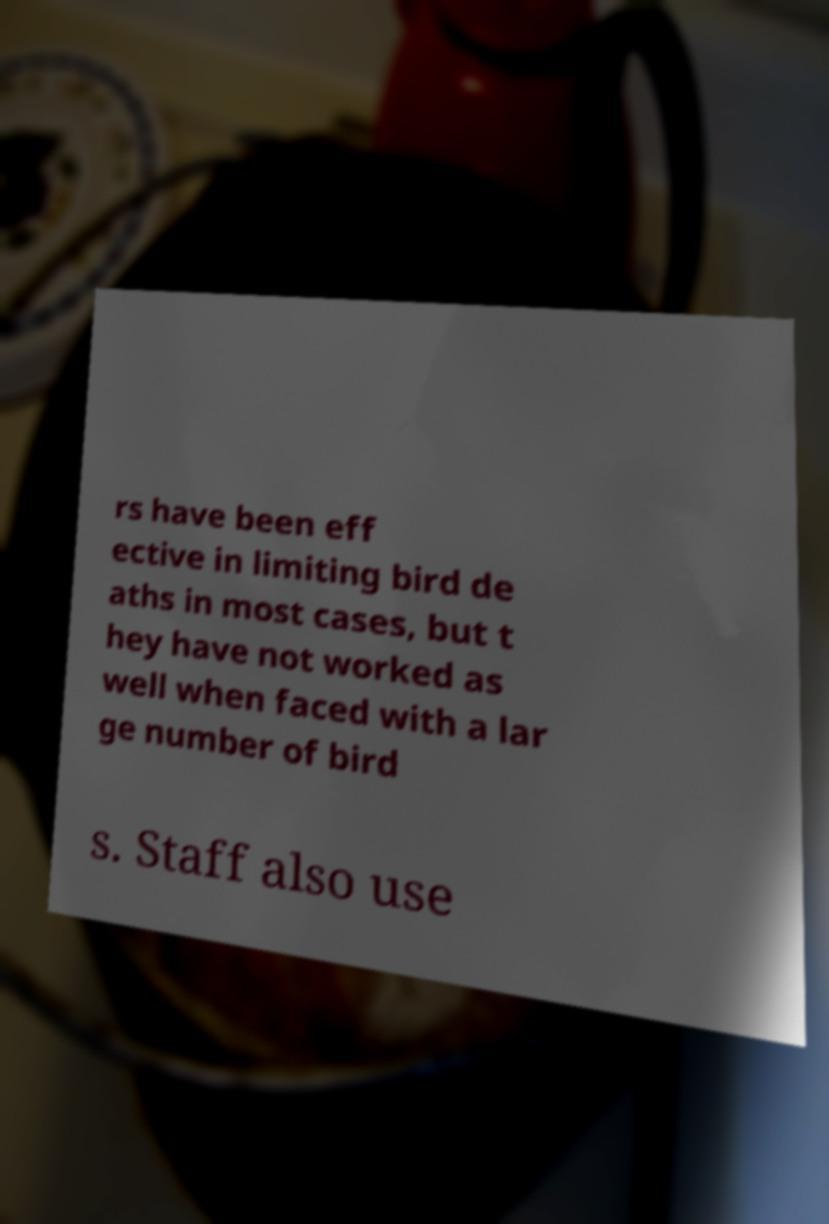There's text embedded in this image that I need extracted. Can you transcribe it verbatim? rs have been eff ective in limiting bird de aths in most cases, but t hey have not worked as well when faced with a lar ge number of bird s. Staff also use 